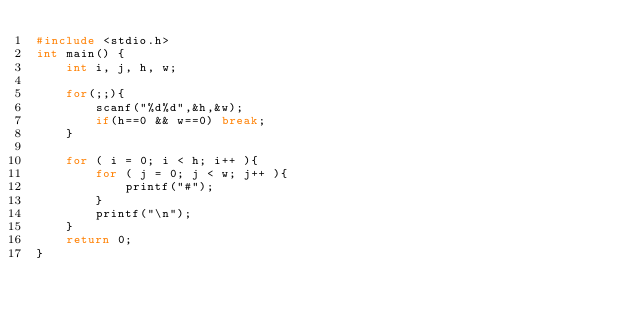<code> <loc_0><loc_0><loc_500><loc_500><_C_>#include <stdio.h>
int main() {
	int i, j, h, w;
	
	for(;;){
		scanf("%d%d",&h,&w);
		if(h==0 && w==0) break;
	}
	
	for ( i = 0; i < h; i++ ){
    	for ( j = 0; j < w; j++ ){
        	printf("#");
    	}
    	printf("\n");
	}
	return 0;
}</code> 